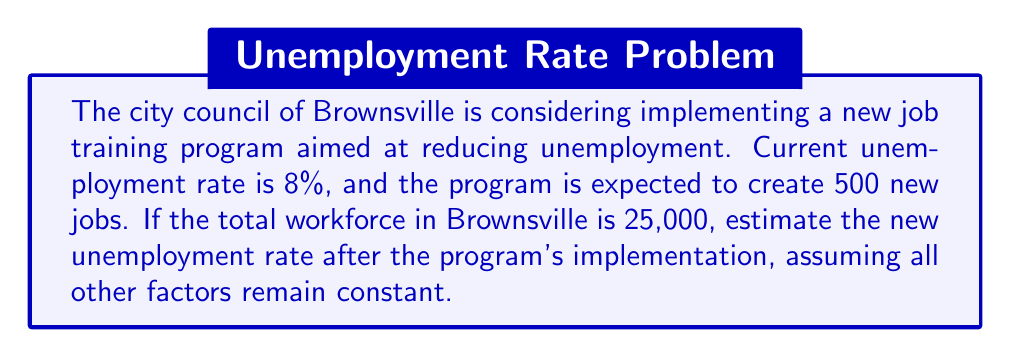What is the answer to this math problem? Let's approach this problem step-by-step:

1) First, we need to calculate the current number of unemployed people:
   $8\% \text{ of } 25,000 = 0.08 \times 25,000 = 2,000$ unemployed people

2) The total number of employed people is therefore:
   $25,000 - 2,000 = 23,000$ employed people

3) The new job training program will create 500 new jobs. Assuming these jobs are filled by currently unemployed individuals, the new numbers will be:
   New employed: $23,000 + 500 = 23,500$
   New unemployed: $2,000 - 500 = 1,500$

4) To calculate the new unemployment rate, we use the formula:
   $\text{Unemployment Rate} = \frac{\text{Number of Unemployed}}{\text{Total Workforce}} \times 100\%$

5) Plugging in our new numbers:
   $$\text{New Unemployment Rate} = \frac{1,500}{25,000} \times 100\% = 0.06 \times 100\% = 6\%$$

Therefore, the estimated new unemployment rate after the implementation of the job training program would be 6%.
Answer: 6% 